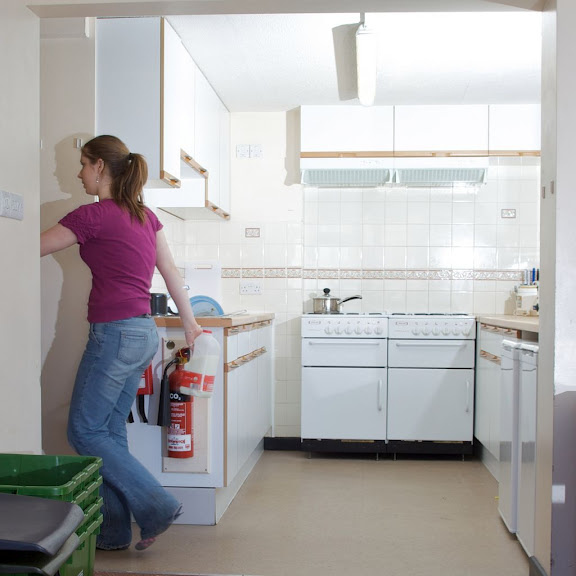Please transcribe the text in this image. co. 